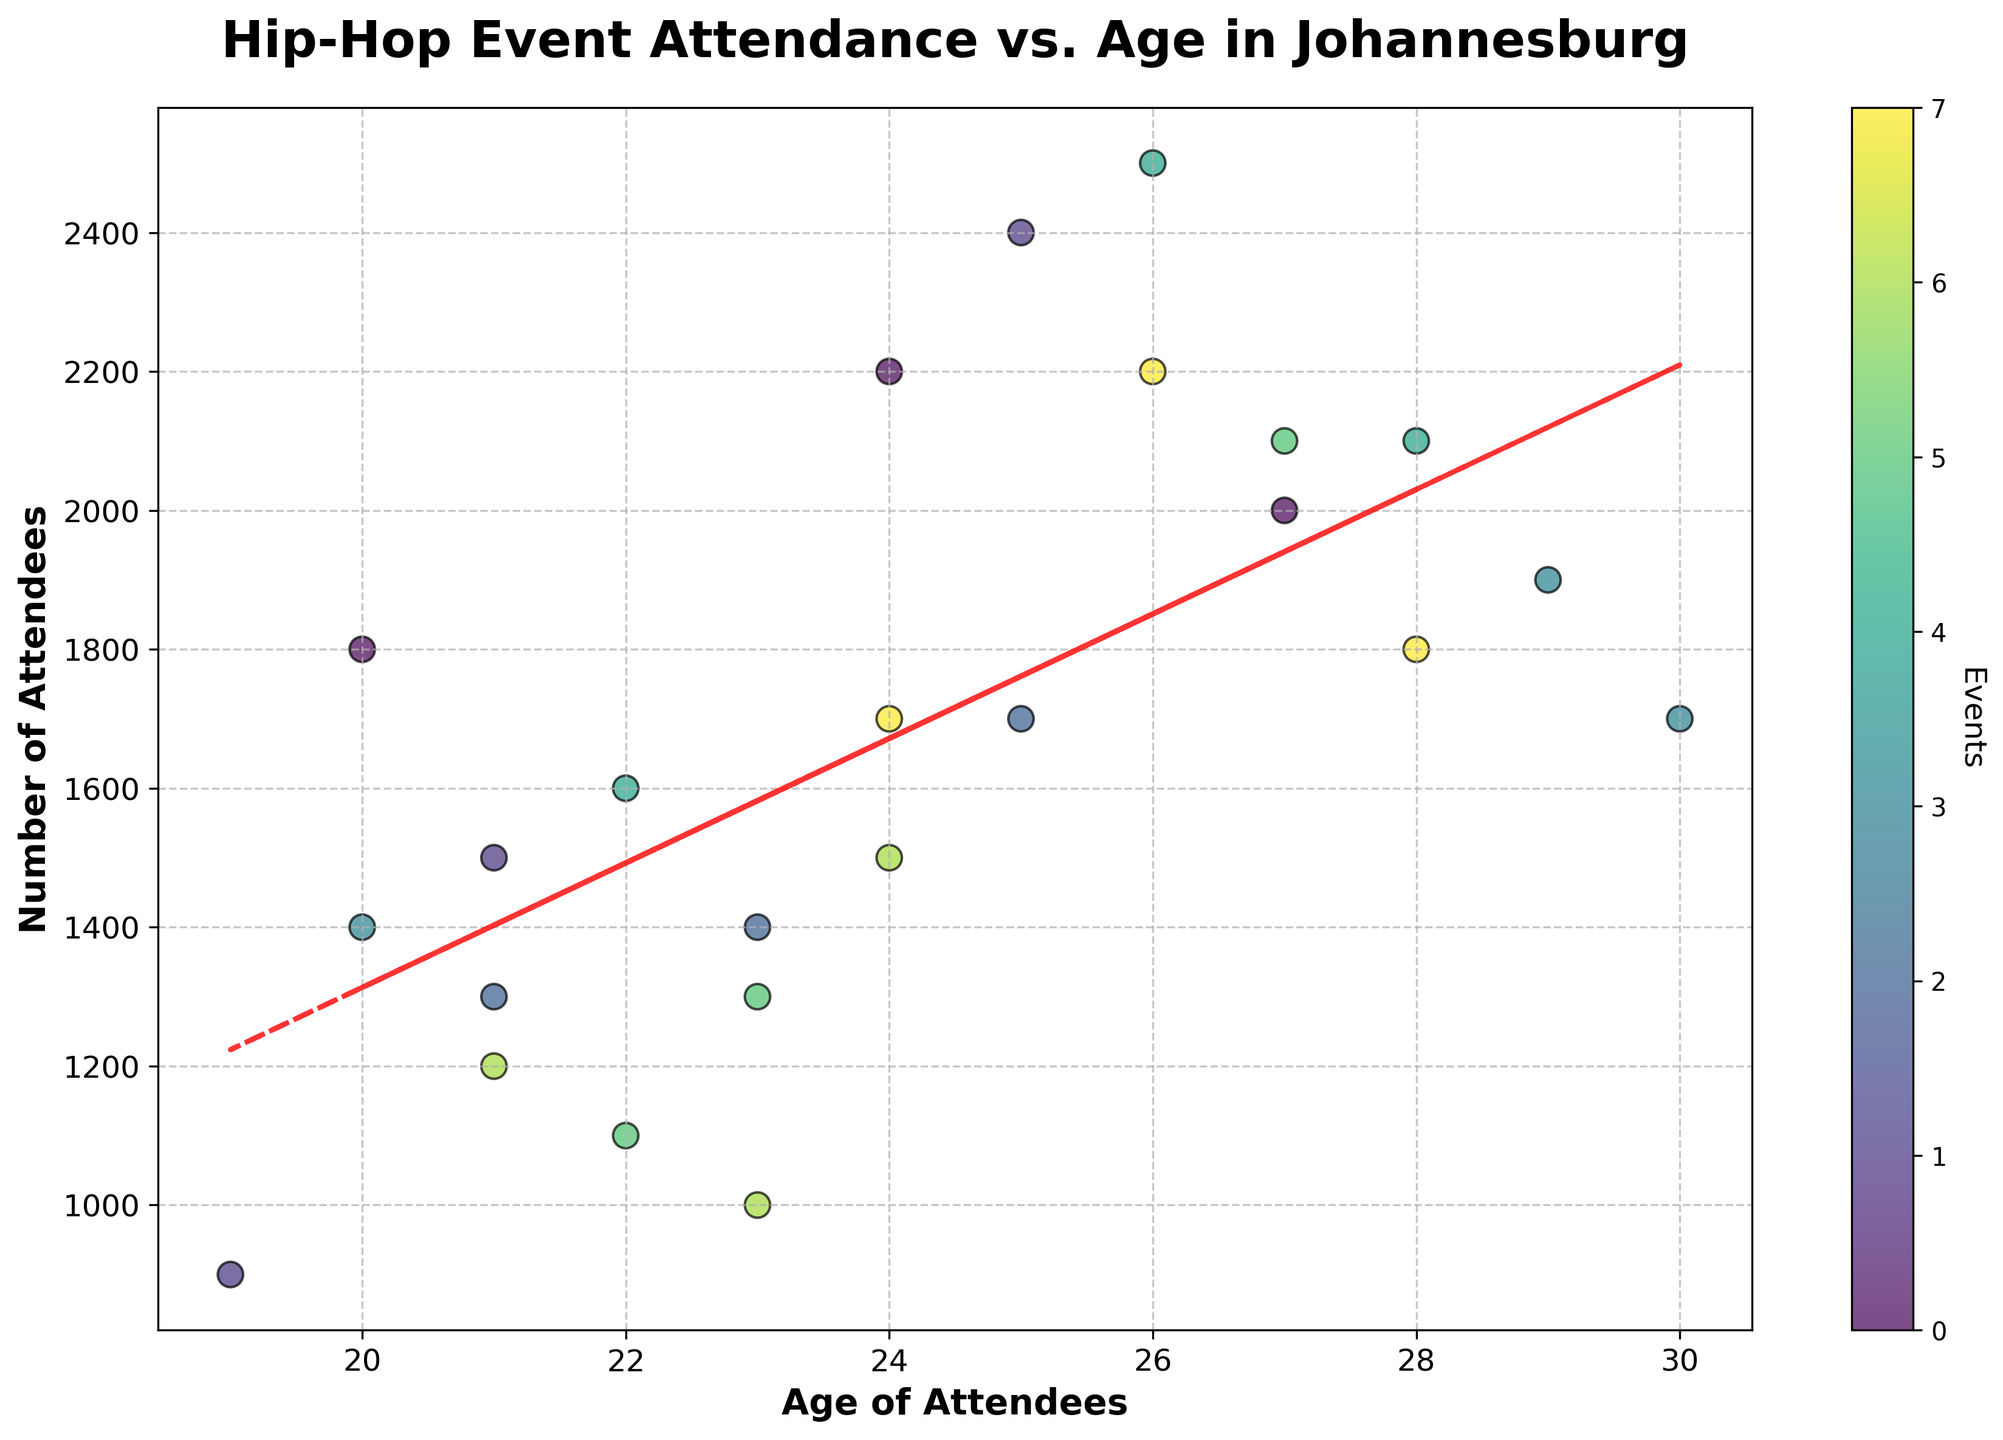How many events are represented in the scatter plot? The scatter plot uses different colors to represent different events. By counting the number of distinct colors in the color bar, we can determine the number of events.
Answer: 8 What is the title of the scatter plot? The title is the text that describes what the figure is about, usually located at the top of the plot. In this case, it looks like "Hip-Hop Event Attendance vs. Age in Johannesburg."
Answer: Hip-Hop Event Attendance vs. Age in Johannesburg What is the relationship between age and the number of attendees according to the trend line? The trend line shows the overall direction of the data points. If the trend line slopes upward, then as age increases, the number of attendees generally increases as well.
Answer: Positive relationship Compare the number of attendees of 21-year-olds and 26-year-olds. Which age group has more attendees? To compare, find the points on the scatter plot for ages 21 and 26 and look at their y-axis values (number of attendees). 21-year-olds have data points at around 1500, 1200, and 1300 while 26-year-olds have points at 2200 and 2500 attendees.
Answer: 26-year-olds What is the average number of attendees for the age group 24-year-olds? Identify the y-values for the data points at age 24 and compute their average. For 24-year-olds, the y-values are 1700, 1500, and 2200. The average is (1700 + 1500 + 2200) / 3 = 5400 / 3.
Answer: 1800 Is there a significant outlier in the number of attendees for any age group? Look for a data point that lies far outside the general distribution of the other points. A big jump from the trend line or other points could indicate an outlier. There doesn't seem to be a drastic outlier in this plot.
Answer: No significant outlier What is the highest number of attendees recorded for a single event, and at what age? Identify the highest point on the y-axis and see to what age it corresponds. The highest number of attendees is 2500 at age 26.
Answer: 2500 at age 26 For events with attendees older than 25, what is the average number of attendees? Identify the points with x-values (ages) greater than 25, then compute the average of their y-values (number of attendees). Points: 2100, 2200, 1900, 1700, 2100, 2000. The average is (2100 + 2200 + 1900 + 1700 + 2100 + 2000) / 6 = 12000 / 6.
Answer: 2000 How does the attendance trend for ages 25, 26, and 27 compare to younger ages like 19, 20, and 21? Compare the average number of attendees for ages 25-27 with ages 19-21. Calculate the averages: 25-27 have 1700, 2200, and 2100 attendees; average is (1700 + 2200 + 2100) / 3 = 6000 / 3. For ages 19-21, the numbers are 900, 1400, and 1800; average is (900 + 1400 + 1800) / 3 = 4100 / 3.
Answer: Higher for ages 25-27 